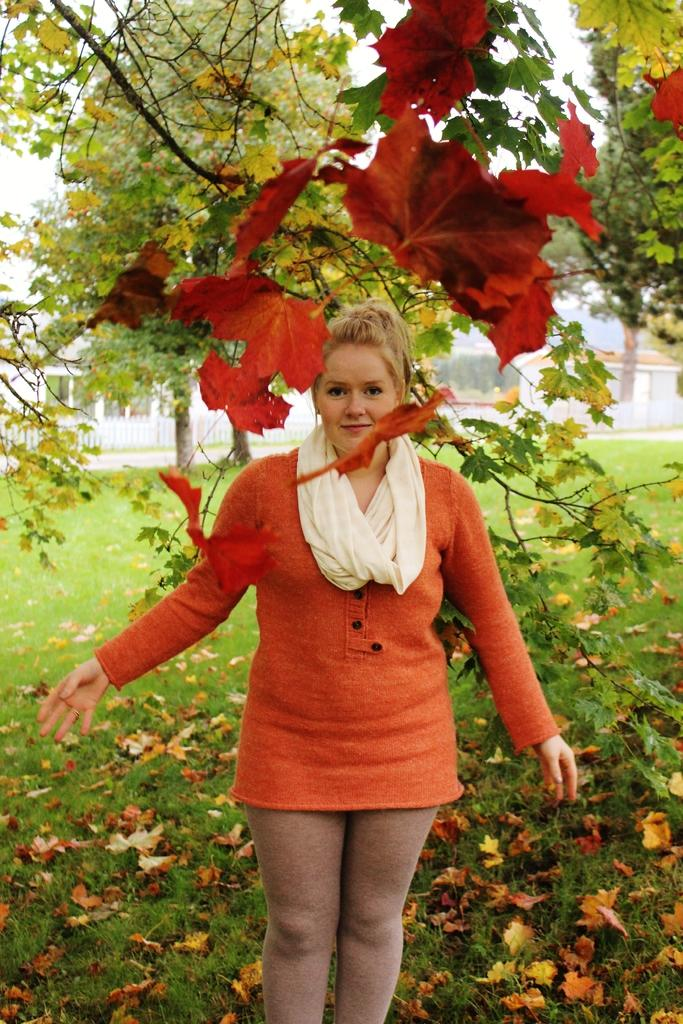Who is present in the image? There is a lady in the image. Where is the lady located in the image? The lady is standing under a tree. What type of surface is the lady standing on? The lady is standing on grass. What can be seen in the background of the image? There is a building visible in the background of the image. What type of pie is the lady holding in the image? There is no pie present in the image; the lady is standing under a tree and on grass. 